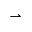Convert formula to latex. <formula><loc_0><loc_0><loc_500><loc_500>\rightharpoonup</formula> 